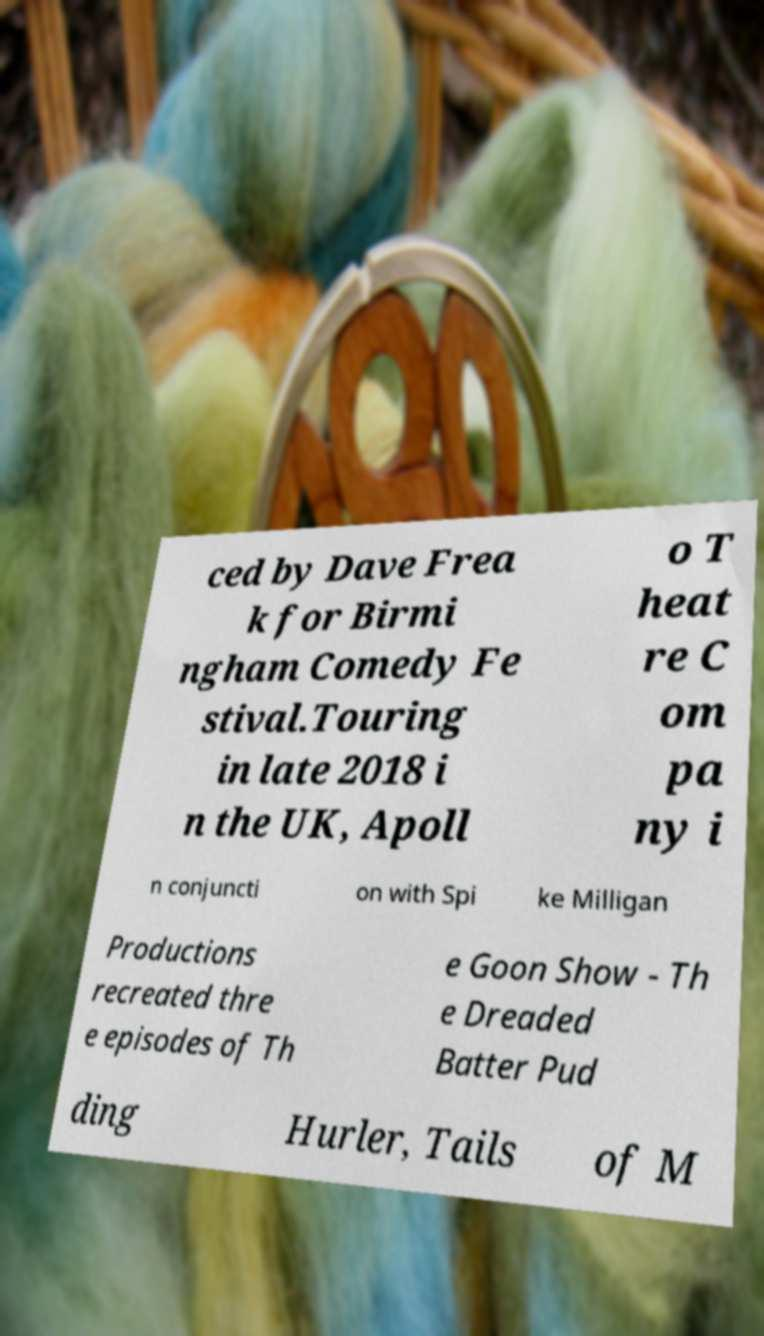Could you assist in decoding the text presented in this image and type it out clearly? ced by Dave Frea k for Birmi ngham Comedy Fe stival.Touring in late 2018 i n the UK, Apoll o T heat re C om pa ny i n conjuncti on with Spi ke Milligan Productions recreated thre e episodes of Th e Goon Show - Th e Dreaded Batter Pud ding Hurler, Tails of M 